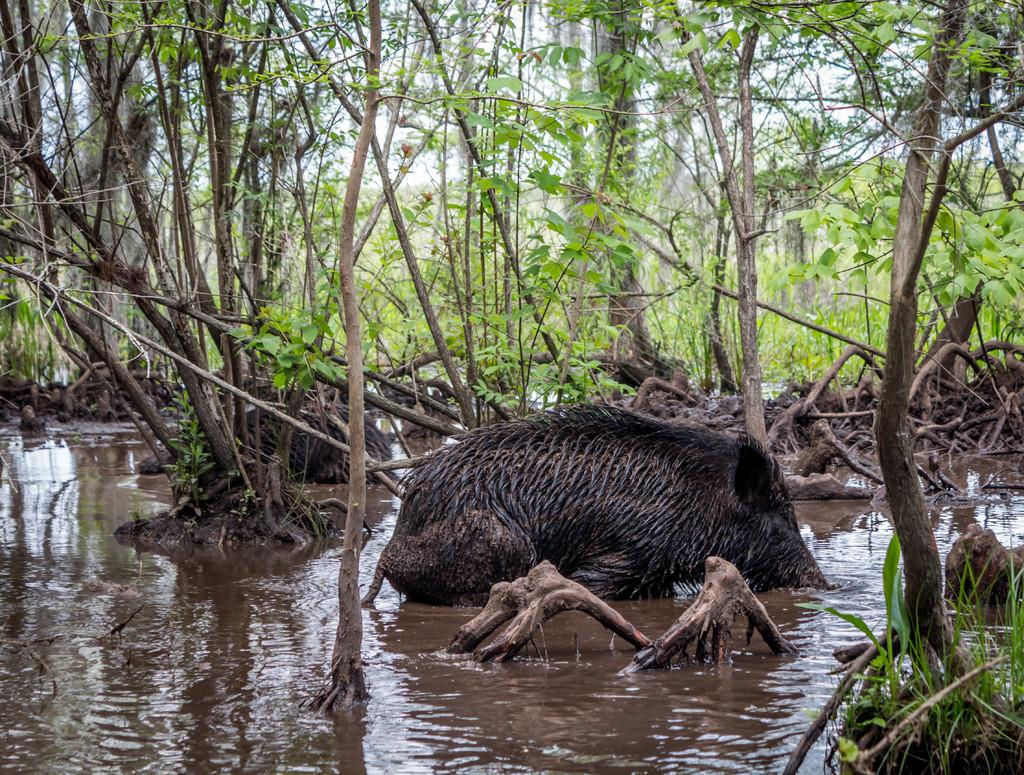What animal is in the water in the image? There is a pig in the water in the image. What type of vegetation can be seen in the image? There are trees visible in the image. What type of glass is the pig drinking from in the image? There is no glass present in the image; the pig is in the water. Can you tell me how many brothers the pig has in the image? There is no information about the pig's family in the image. 